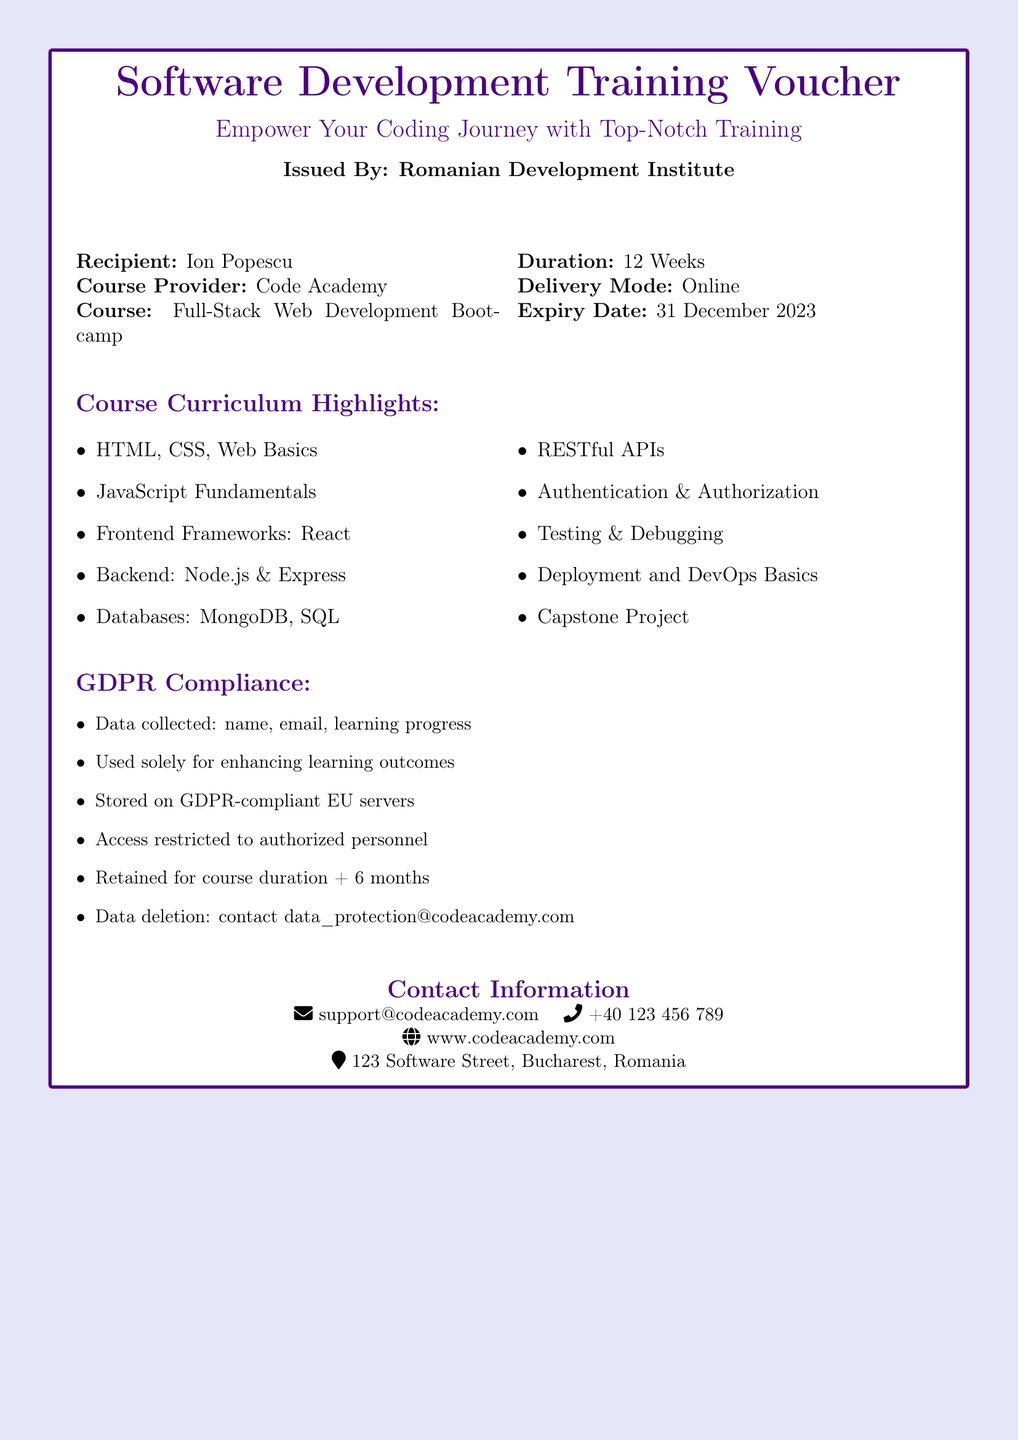What is the name of the recipient? The recipient's name is explicitly mentioned in the document as "Ion Popescu."
Answer: Ion Popescu What is the course provided? The document states the course title as "Full-Stack Web Development Bootcamp."
Answer: Full-Stack Web Development Bootcamp How long is the course duration? The document specifies the course duration as "12 Weeks."
Answer: 12 Weeks What is the expiry date of the voucher? The expiry date is listed in the document as "31 December 2023."
Answer: 31 December 2023 Where is the course provider located? The document mentions the course provider's address as "123 Software Street, Bucharest, Romania."
Answer: 123 Software Street, Bucharest, Romania What type of data is collected? The document lists the collected data as "name, email, learning progress."
Answer: name, email, learning progress How long is data retained after the course ends? The document states that the data is retained for "course duration + 6 months."
Answer: course duration + 6 months What is used to enhance learning outcomes? The document indicates that the collected data is used "solely for enhancing learning outcomes."
Answer: enhancing learning outcomes Which framework is covered in the curriculum? The document mentions "React" as a frontend framework included in the curriculum.
Answer: React What is the contact email for data deletion? The document provides the contact email for data deletion as "data_protection@codeacademy.com."
Answer: data_protection@codeacademy.com 